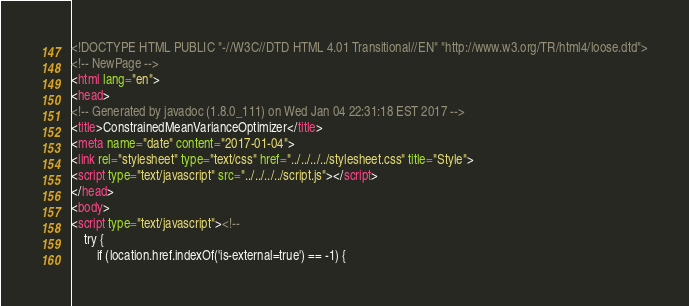Convert code to text. <code><loc_0><loc_0><loc_500><loc_500><_HTML_><!DOCTYPE HTML PUBLIC "-//W3C//DTD HTML 4.01 Transitional//EN" "http://www.w3.org/TR/html4/loose.dtd">
<!-- NewPage -->
<html lang="en">
<head>
<!-- Generated by javadoc (1.8.0_111) on Wed Jan 04 22:31:18 EST 2017 -->
<title>ConstrainedMeanVarianceOptimizer</title>
<meta name="date" content="2017-01-04">
<link rel="stylesheet" type="text/css" href="../../../../stylesheet.css" title="Style">
<script type="text/javascript" src="../../../../script.js"></script>
</head>
<body>
<script type="text/javascript"><!--
    try {
        if (location.href.indexOf('is-external=true') == -1) {</code> 